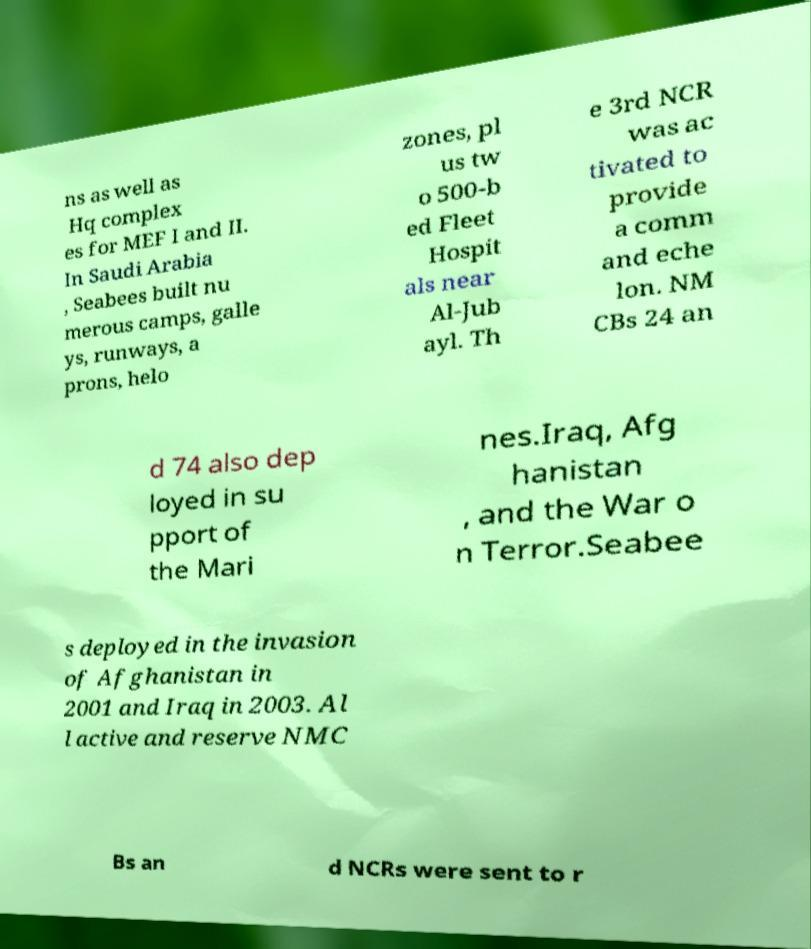Can you accurately transcribe the text from the provided image for me? ns as well as Hq complex es for MEF I and II. In Saudi Arabia , Seabees built nu merous camps, galle ys, runways, a prons, helo zones, pl us tw o 500-b ed Fleet Hospit als near Al-Jub ayl. Th e 3rd NCR was ac tivated to provide a comm and eche lon. NM CBs 24 an d 74 also dep loyed in su pport of the Mari nes.Iraq, Afg hanistan , and the War o n Terror.Seabee s deployed in the invasion of Afghanistan in 2001 and Iraq in 2003. Al l active and reserve NMC Bs an d NCRs were sent to r 